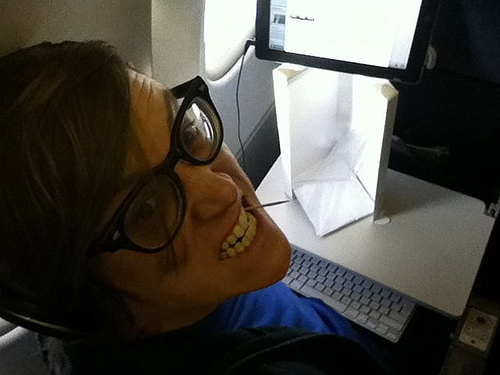What is the guy holding in his mouth? The guy appears to be holding something in his mouth, perhaps a toothpick or a small stick. 